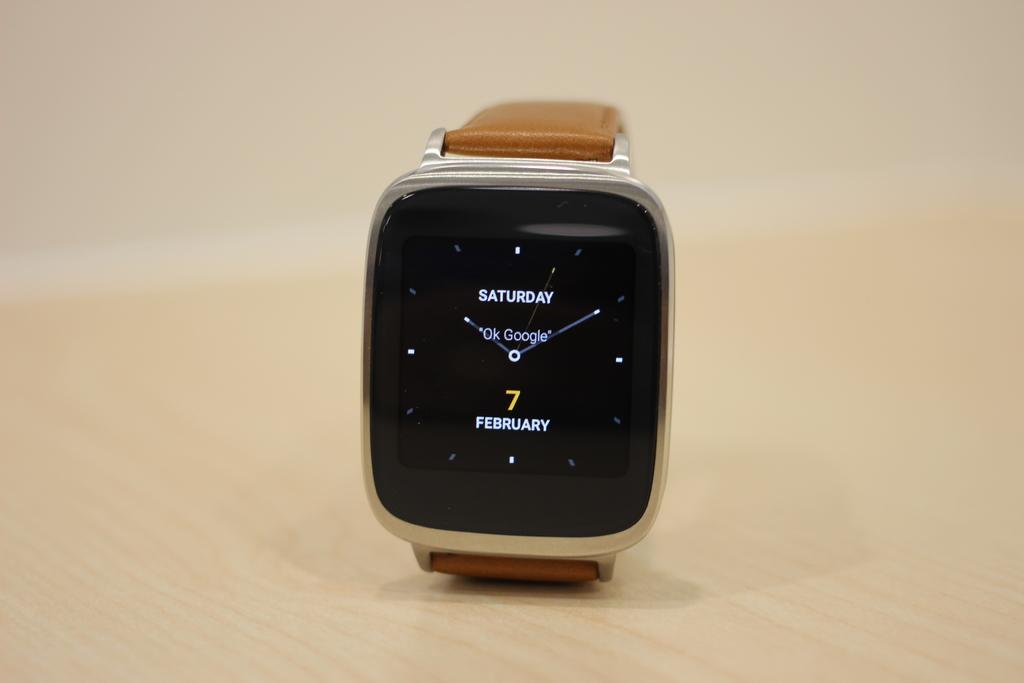<image>
Give a short and clear explanation of the subsequent image. A smart watch says Saturday 7 February and is on a wooden table. 